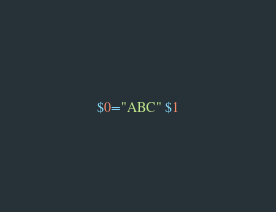Convert code to text. <code><loc_0><loc_0><loc_500><loc_500><_Awk_>$0="ABC" $1</code> 